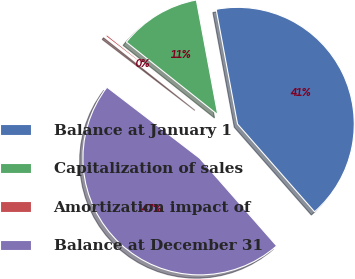Convert chart to OTSL. <chart><loc_0><loc_0><loc_500><loc_500><pie_chart><fcel>Balance at January 1<fcel>Capitalization of sales<fcel>Amortization impact of<fcel>Balance at December 31<nl><fcel>41.47%<fcel>11.38%<fcel>0.28%<fcel>46.88%<nl></chart> 